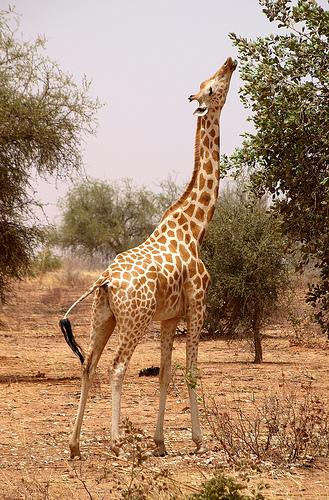Is the giraffe taller than the trees?
Give a very brief answer. No. Is the giraffe eating?
Write a very short answer. Yes. Where are the animals?
Write a very short answer. Giraffe. Is this an adult giraffe?
Write a very short answer. Yes. Are the giraffes all adults?
Answer briefly. Yes. What type of environment are these animals in?
Write a very short answer. Zoo. Are the giraffes hungry?
Answer briefly. Yes. Do all the trees have leaves?
Keep it brief. Yes. What is the giraffe doing to the tree?
Short answer required. Eating. What is the giraffe's tail doing?
Answer briefly. Nothing. Are the giraffe eating?
Be succinct. Yes. Where is this at?
Quick response, please. Africa. 